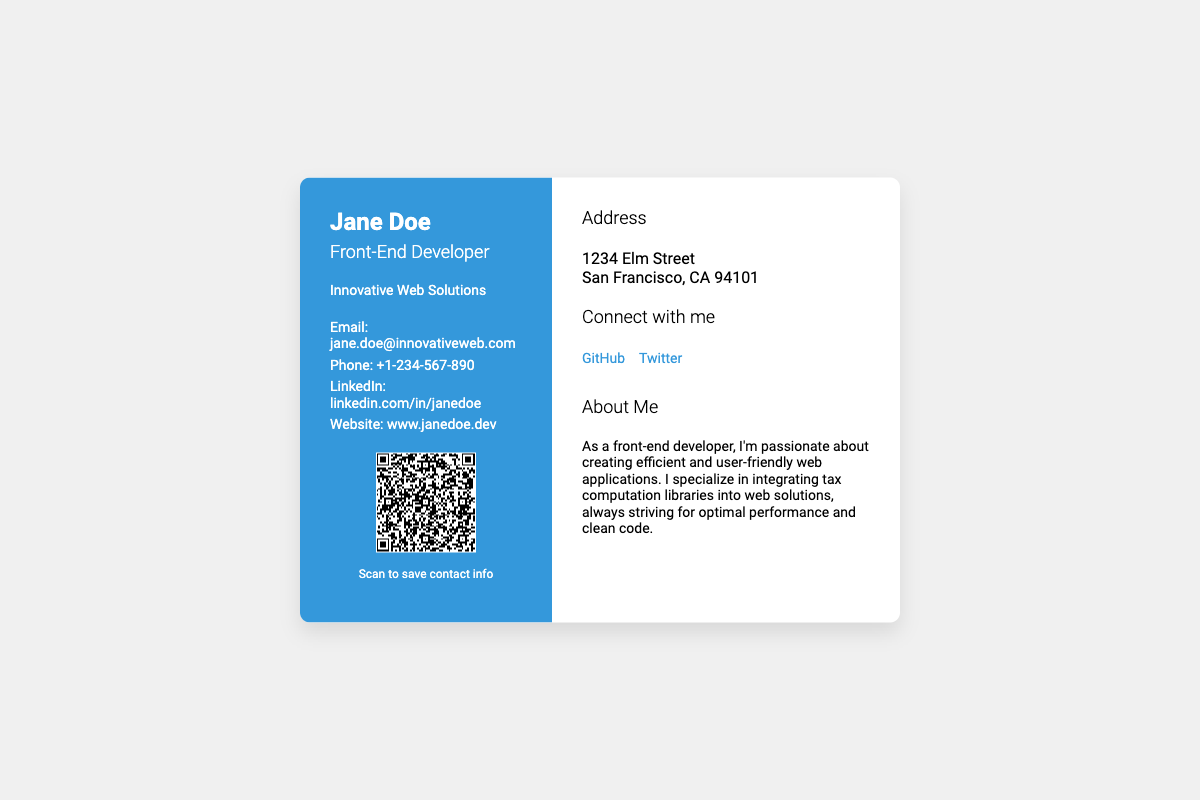What is the name of the front-end developer? The document clearly states the name at the top of the business card.
Answer: Jane Doe What is the title of Jane Doe? The title is mentioned prominently under her name.
Answer: Front-End Developer What company does Jane Doe work for? The company name is included in the left column of the card.
Answer: Innovative Web Solutions What is Jane Doe's email address? The email address is provided in the contact information section.
Answer: jane.doe@innovativeweb.com What is Jane Doe's phone number? The phone number is listed in the contact information section.
Answer: +1-234-567-890 Where is Jane Doe located? The address is provided in the right column under the address section.
Answer: 1234 Elm Street, San Francisco, CA 94101 What social media platform is linked on the card? Several social media links are provided, focusing on the ones specified in the social media section.
Answer: GitHub What can be scanned to save Jane's contact info? The QR code is specifically for saving contact information.
Answer: QR Code What is the size of the QR code image? The information about the QR code dimensions is included within the HTML image tag.
Answer: 100x100 